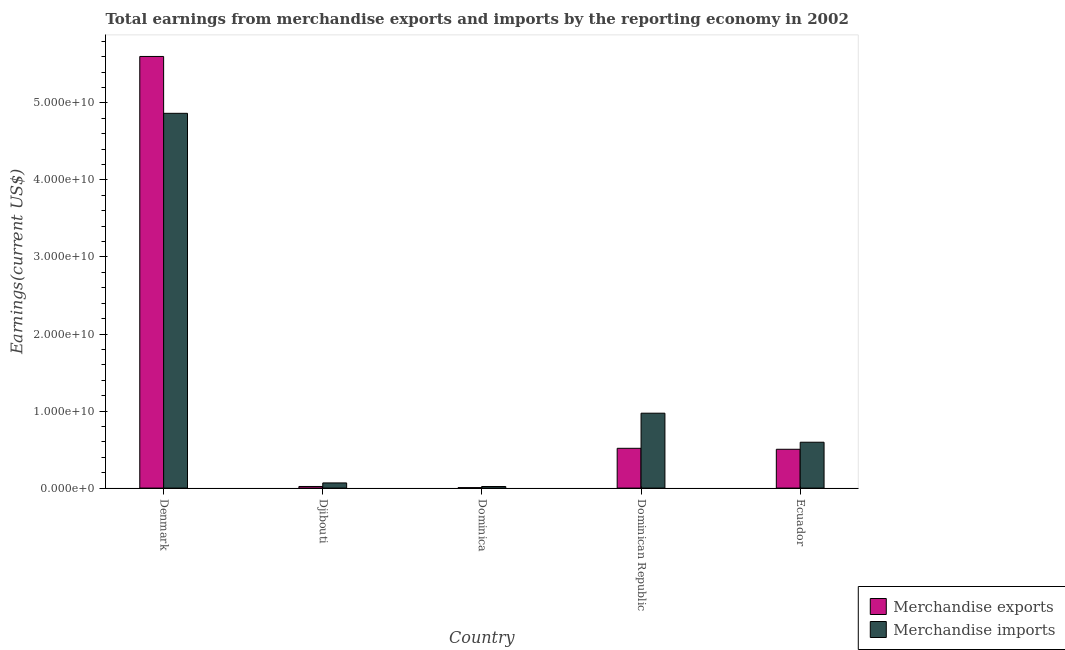How many groups of bars are there?
Your answer should be compact. 5. How many bars are there on the 4th tick from the left?
Your response must be concise. 2. What is the label of the 2nd group of bars from the left?
Keep it short and to the point. Djibouti. In how many cases, is the number of bars for a given country not equal to the number of legend labels?
Your response must be concise. 0. What is the earnings from merchandise imports in Denmark?
Your answer should be very brief. 4.86e+1. Across all countries, what is the maximum earnings from merchandise exports?
Offer a very short reply. 5.60e+1. Across all countries, what is the minimum earnings from merchandise imports?
Your answer should be compact. 2.05e+08. In which country was the earnings from merchandise imports minimum?
Your answer should be compact. Dominica. What is the total earnings from merchandise imports in the graph?
Make the answer very short. 6.52e+1. What is the difference between the earnings from merchandise exports in Denmark and that in Dominica?
Ensure brevity in your answer.  5.60e+1. What is the difference between the earnings from merchandise imports in Djibouti and the earnings from merchandise exports in Dominican Republic?
Make the answer very short. -4.49e+09. What is the average earnings from merchandise exports per country?
Offer a very short reply. 1.33e+1. What is the difference between the earnings from merchandise exports and earnings from merchandise imports in Ecuador?
Offer a very short reply. -9.15e+08. What is the ratio of the earnings from merchandise imports in Djibouti to that in Dominican Republic?
Make the answer very short. 0.07. Is the difference between the earnings from merchandise imports in Denmark and Djibouti greater than the difference between the earnings from merchandise exports in Denmark and Djibouti?
Your answer should be compact. No. What is the difference between the highest and the second highest earnings from merchandise imports?
Provide a short and direct response. 3.89e+1. What is the difference between the highest and the lowest earnings from merchandise exports?
Offer a very short reply. 5.60e+1. Is the sum of the earnings from merchandise exports in Djibouti and Dominican Republic greater than the maximum earnings from merchandise imports across all countries?
Offer a very short reply. No. What does the 2nd bar from the left in Dominica represents?
Provide a succinct answer. Merchandise imports. Are all the bars in the graph horizontal?
Make the answer very short. No. How many countries are there in the graph?
Provide a short and direct response. 5. Are the values on the major ticks of Y-axis written in scientific E-notation?
Provide a succinct answer. Yes. Does the graph contain grids?
Your answer should be compact. No. How are the legend labels stacked?
Offer a very short reply. Vertical. What is the title of the graph?
Your response must be concise. Total earnings from merchandise exports and imports by the reporting economy in 2002. Does "Food" appear as one of the legend labels in the graph?
Make the answer very short. No. What is the label or title of the X-axis?
Keep it short and to the point. Country. What is the label or title of the Y-axis?
Make the answer very short. Earnings(current US$). What is the Earnings(current US$) in Merchandise exports in Denmark?
Your answer should be compact. 5.60e+1. What is the Earnings(current US$) of Merchandise imports in Denmark?
Provide a short and direct response. 4.86e+1. What is the Earnings(current US$) in Merchandise exports in Djibouti?
Ensure brevity in your answer.  2.09e+08. What is the Earnings(current US$) in Merchandise imports in Djibouti?
Give a very brief answer. 6.71e+08. What is the Earnings(current US$) in Merchandise exports in Dominica?
Your response must be concise. 6.06e+07. What is the Earnings(current US$) in Merchandise imports in Dominica?
Provide a short and direct response. 2.05e+08. What is the Earnings(current US$) in Merchandise exports in Dominican Republic?
Give a very brief answer. 5.16e+09. What is the Earnings(current US$) in Merchandise imports in Dominican Republic?
Ensure brevity in your answer.  9.72e+09. What is the Earnings(current US$) of Merchandise exports in Ecuador?
Keep it short and to the point. 5.04e+09. What is the Earnings(current US$) of Merchandise imports in Ecuador?
Provide a short and direct response. 5.95e+09. Across all countries, what is the maximum Earnings(current US$) in Merchandise exports?
Your answer should be compact. 5.60e+1. Across all countries, what is the maximum Earnings(current US$) of Merchandise imports?
Keep it short and to the point. 4.86e+1. Across all countries, what is the minimum Earnings(current US$) of Merchandise exports?
Your answer should be very brief. 6.06e+07. Across all countries, what is the minimum Earnings(current US$) of Merchandise imports?
Your answer should be very brief. 2.05e+08. What is the total Earnings(current US$) of Merchandise exports in the graph?
Your response must be concise. 6.65e+1. What is the total Earnings(current US$) of Merchandise imports in the graph?
Keep it short and to the point. 6.52e+1. What is the difference between the Earnings(current US$) in Merchandise exports in Denmark and that in Djibouti?
Give a very brief answer. 5.58e+1. What is the difference between the Earnings(current US$) of Merchandise imports in Denmark and that in Djibouti?
Your answer should be very brief. 4.80e+1. What is the difference between the Earnings(current US$) in Merchandise exports in Denmark and that in Dominica?
Give a very brief answer. 5.60e+1. What is the difference between the Earnings(current US$) in Merchandise imports in Denmark and that in Dominica?
Your answer should be compact. 4.84e+1. What is the difference between the Earnings(current US$) of Merchandise exports in Denmark and that in Dominican Republic?
Make the answer very short. 5.09e+1. What is the difference between the Earnings(current US$) in Merchandise imports in Denmark and that in Dominican Republic?
Provide a succinct answer. 3.89e+1. What is the difference between the Earnings(current US$) of Merchandise exports in Denmark and that in Ecuador?
Ensure brevity in your answer.  5.10e+1. What is the difference between the Earnings(current US$) in Merchandise imports in Denmark and that in Ecuador?
Offer a very short reply. 4.27e+1. What is the difference between the Earnings(current US$) of Merchandise exports in Djibouti and that in Dominica?
Give a very brief answer. 1.48e+08. What is the difference between the Earnings(current US$) in Merchandise imports in Djibouti and that in Dominica?
Provide a short and direct response. 4.66e+08. What is the difference between the Earnings(current US$) in Merchandise exports in Djibouti and that in Dominican Republic?
Offer a very short reply. -4.96e+09. What is the difference between the Earnings(current US$) of Merchandise imports in Djibouti and that in Dominican Republic?
Provide a succinct answer. -9.05e+09. What is the difference between the Earnings(current US$) in Merchandise exports in Djibouti and that in Ecuador?
Offer a terse response. -4.83e+09. What is the difference between the Earnings(current US$) in Merchandise imports in Djibouti and that in Ecuador?
Make the answer very short. -5.28e+09. What is the difference between the Earnings(current US$) of Merchandise exports in Dominica and that in Dominican Republic?
Ensure brevity in your answer.  -5.10e+09. What is the difference between the Earnings(current US$) in Merchandise imports in Dominica and that in Dominican Republic?
Make the answer very short. -9.52e+09. What is the difference between the Earnings(current US$) in Merchandise exports in Dominica and that in Ecuador?
Offer a very short reply. -4.98e+09. What is the difference between the Earnings(current US$) in Merchandise imports in Dominica and that in Ecuador?
Offer a very short reply. -5.75e+09. What is the difference between the Earnings(current US$) in Merchandise exports in Dominican Republic and that in Ecuador?
Keep it short and to the point. 1.27e+08. What is the difference between the Earnings(current US$) in Merchandise imports in Dominican Republic and that in Ecuador?
Offer a terse response. 3.77e+09. What is the difference between the Earnings(current US$) in Merchandise exports in Denmark and the Earnings(current US$) in Merchandise imports in Djibouti?
Offer a terse response. 5.54e+1. What is the difference between the Earnings(current US$) in Merchandise exports in Denmark and the Earnings(current US$) in Merchandise imports in Dominica?
Your answer should be very brief. 5.58e+1. What is the difference between the Earnings(current US$) of Merchandise exports in Denmark and the Earnings(current US$) of Merchandise imports in Dominican Republic?
Make the answer very short. 4.63e+1. What is the difference between the Earnings(current US$) in Merchandise exports in Denmark and the Earnings(current US$) in Merchandise imports in Ecuador?
Offer a very short reply. 5.01e+1. What is the difference between the Earnings(current US$) of Merchandise exports in Djibouti and the Earnings(current US$) of Merchandise imports in Dominica?
Offer a very short reply. 4.15e+06. What is the difference between the Earnings(current US$) in Merchandise exports in Djibouti and the Earnings(current US$) in Merchandise imports in Dominican Republic?
Offer a terse response. -9.51e+09. What is the difference between the Earnings(current US$) in Merchandise exports in Djibouti and the Earnings(current US$) in Merchandise imports in Ecuador?
Offer a very short reply. -5.74e+09. What is the difference between the Earnings(current US$) in Merchandise exports in Dominica and the Earnings(current US$) in Merchandise imports in Dominican Republic?
Your response must be concise. -9.66e+09. What is the difference between the Earnings(current US$) of Merchandise exports in Dominica and the Earnings(current US$) of Merchandise imports in Ecuador?
Provide a short and direct response. -5.89e+09. What is the difference between the Earnings(current US$) of Merchandise exports in Dominican Republic and the Earnings(current US$) of Merchandise imports in Ecuador?
Offer a terse response. -7.88e+08. What is the average Earnings(current US$) of Merchandise exports per country?
Make the answer very short. 1.33e+1. What is the average Earnings(current US$) in Merchandise imports per country?
Offer a very short reply. 1.30e+1. What is the difference between the Earnings(current US$) in Merchandise exports and Earnings(current US$) in Merchandise imports in Denmark?
Offer a very short reply. 7.38e+09. What is the difference between the Earnings(current US$) in Merchandise exports and Earnings(current US$) in Merchandise imports in Djibouti?
Offer a terse response. -4.62e+08. What is the difference between the Earnings(current US$) in Merchandise exports and Earnings(current US$) in Merchandise imports in Dominica?
Your answer should be compact. -1.44e+08. What is the difference between the Earnings(current US$) of Merchandise exports and Earnings(current US$) of Merchandise imports in Dominican Republic?
Your response must be concise. -4.56e+09. What is the difference between the Earnings(current US$) of Merchandise exports and Earnings(current US$) of Merchandise imports in Ecuador?
Offer a terse response. -9.15e+08. What is the ratio of the Earnings(current US$) of Merchandise exports in Denmark to that in Djibouti?
Your answer should be very brief. 268.25. What is the ratio of the Earnings(current US$) in Merchandise imports in Denmark to that in Djibouti?
Ensure brevity in your answer.  72.51. What is the ratio of the Earnings(current US$) in Merchandise exports in Denmark to that in Dominica?
Make the answer very short. 924.31. What is the ratio of the Earnings(current US$) of Merchandise imports in Denmark to that in Dominica?
Keep it short and to the point. 237.63. What is the ratio of the Earnings(current US$) of Merchandise exports in Denmark to that in Dominican Republic?
Your answer should be very brief. 10.85. What is the ratio of the Earnings(current US$) in Merchandise imports in Denmark to that in Dominican Republic?
Keep it short and to the point. 5. What is the ratio of the Earnings(current US$) of Merchandise exports in Denmark to that in Ecuador?
Your answer should be very brief. 11.12. What is the ratio of the Earnings(current US$) in Merchandise imports in Denmark to that in Ecuador?
Provide a short and direct response. 8.17. What is the ratio of the Earnings(current US$) of Merchandise exports in Djibouti to that in Dominica?
Make the answer very short. 3.45. What is the ratio of the Earnings(current US$) in Merchandise imports in Djibouti to that in Dominica?
Offer a very short reply. 3.28. What is the ratio of the Earnings(current US$) of Merchandise exports in Djibouti to that in Dominican Republic?
Keep it short and to the point. 0.04. What is the ratio of the Earnings(current US$) of Merchandise imports in Djibouti to that in Dominican Republic?
Your answer should be compact. 0.07. What is the ratio of the Earnings(current US$) of Merchandise exports in Djibouti to that in Ecuador?
Provide a short and direct response. 0.04. What is the ratio of the Earnings(current US$) in Merchandise imports in Djibouti to that in Ecuador?
Your answer should be compact. 0.11. What is the ratio of the Earnings(current US$) of Merchandise exports in Dominica to that in Dominican Republic?
Your response must be concise. 0.01. What is the ratio of the Earnings(current US$) of Merchandise imports in Dominica to that in Dominican Republic?
Your answer should be compact. 0.02. What is the ratio of the Earnings(current US$) of Merchandise exports in Dominica to that in Ecuador?
Your response must be concise. 0.01. What is the ratio of the Earnings(current US$) of Merchandise imports in Dominica to that in Ecuador?
Provide a short and direct response. 0.03. What is the ratio of the Earnings(current US$) of Merchandise exports in Dominican Republic to that in Ecuador?
Give a very brief answer. 1.03. What is the ratio of the Earnings(current US$) of Merchandise imports in Dominican Republic to that in Ecuador?
Your response must be concise. 1.63. What is the difference between the highest and the second highest Earnings(current US$) in Merchandise exports?
Provide a succinct answer. 5.09e+1. What is the difference between the highest and the second highest Earnings(current US$) in Merchandise imports?
Ensure brevity in your answer.  3.89e+1. What is the difference between the highest and the lowest Earnings(current US$) in Merchandise exports?
Your answer should be compact. 5.60e+1. What is the difference between the highest and the lowest Earnings(current US$) of Merchandise imports?
Offer a very short reply. 4.84e+1. 